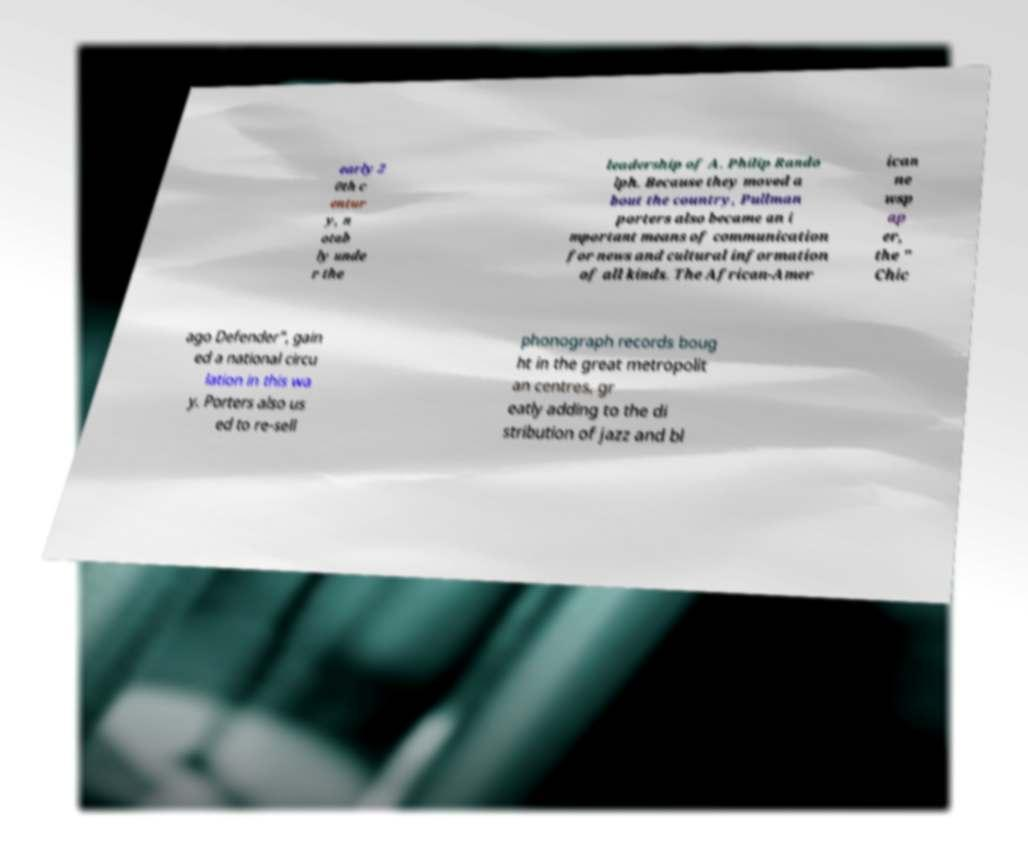Could you extract and type out the text from this image? early 2 0th c entur y, n otab ly unde r the leadership of A. Philip Rando lph. Because they moved a bout the country, Pullman porters also became an i mportant means of communication for news and cultural information of all kinds. The African-Amer ican ne wsp ap er, the " Chic ago Defender", gain ed a national circu lation in this wa y. Porters also us ed to re-sell phonograph records boug ht in the great metropolit an centres, gr eatly adding to the di stribution of jazz and bl 